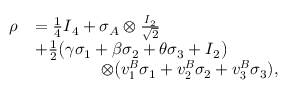Convert formula to latex. <formula><loc_0><loc_0><loc_500><loc_500>\begin{array} { r l } { \rho } & { = \frac { 1 } { 4 } I _ { 4 } + \sigma _ { A } \otimes \frac { I _ { 2 } } { \sqrt { 2 } } } \\ & { + \frac { 1 } { 2 } \Big ( \gamma \sigma _ { 1 } + \beta \sigma _ { 2 } + \theta \sigma _ { 3 } + I _ { 2 } \Big ) } \\ & { \quad \otimes \Big ( v _ { 1 } ^ { B } \sigma _ { 1 } + v _ { 2 } ^ { B } \sigma _ { 2 } + v _ { 3 } ^ { B } \sigma _ { 3 } ) , } \end{array}</formula> 